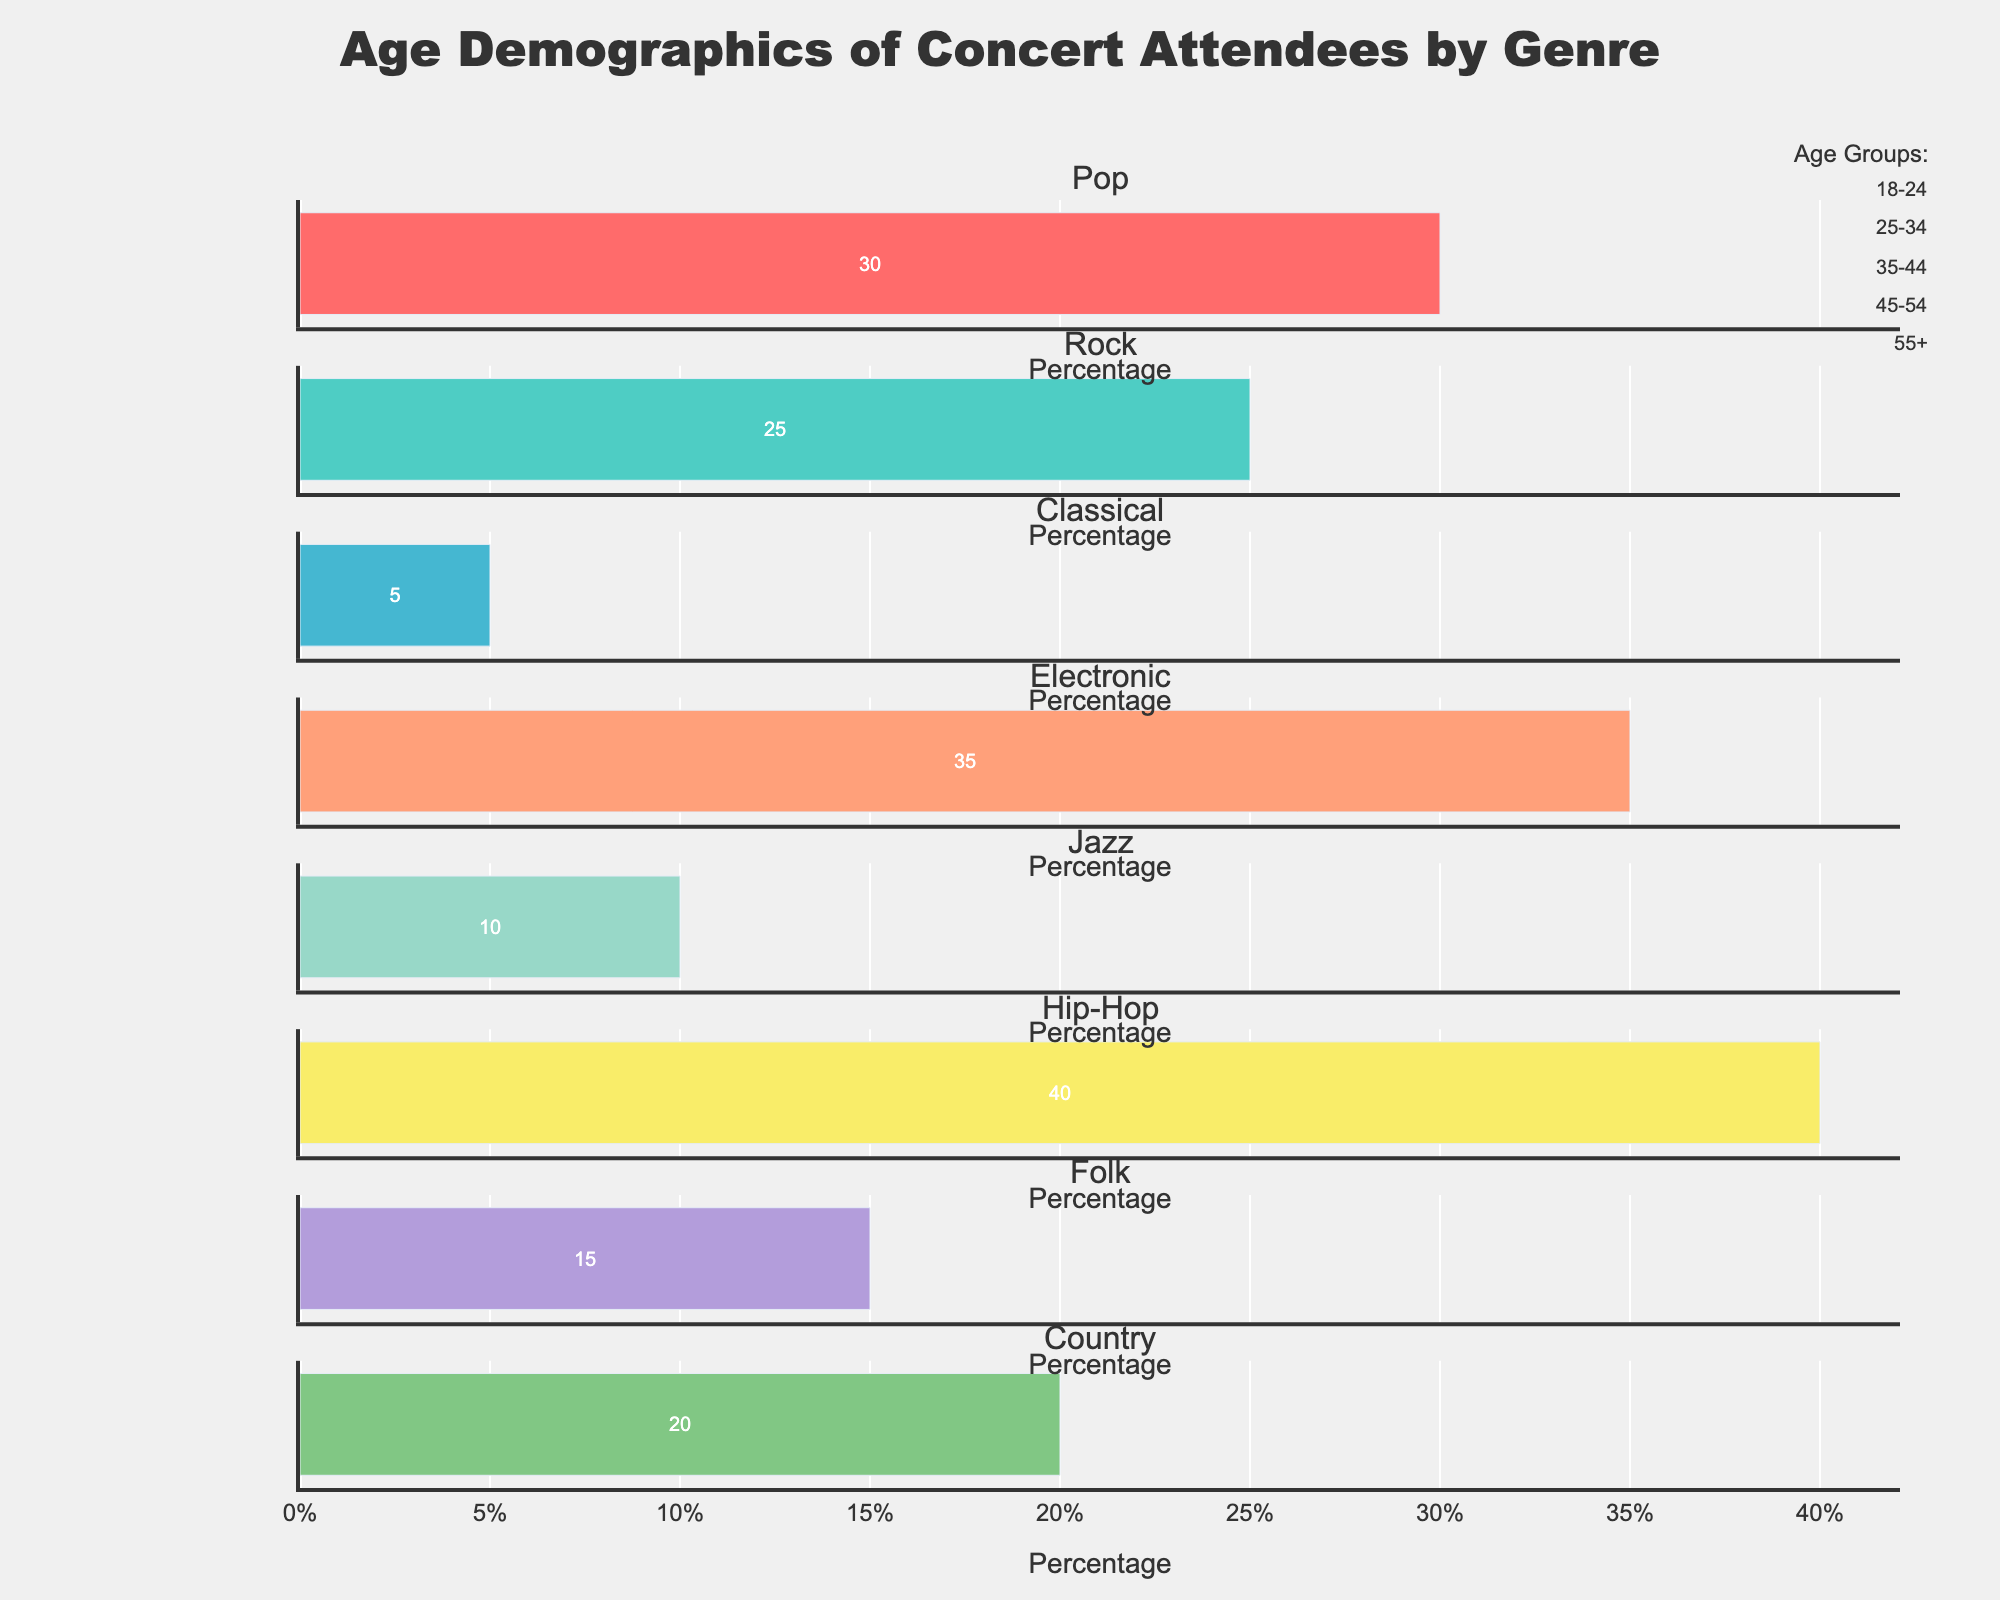What's the title of the figure? The title of the figure is located at the top and center of the plot. It is clearly displayed in bold text.
Answer: Age Demographics of Concert Attendees by Genre Which age group has the highest percentage attendance for Pop music? For Pop music, the age group with the highest percentage is represented by the longest bar under the Pop music subplot.
Answer: 18-24 How does the attendance of the 25-34 age group in Classical music compare to Electronic music? To find this, observe the lengths of the bars under the '25-34' category for both Classical and Electronic music genres.
Answer: In Classical music, it's 10%, and in Electronic music, it's 30% Which music genre has the least variation in age demographics? To determine this, we need to look at the subplot with bars of roughly equal lengths across all age groups.
Answer: Jazz What is the combined percentage of attendees aged 35 and above in Rock music? Sum the percentages of the '35-44', '45-54', and '55+' age groups for Rock music (25% + 15% + 5%).
Answer: 45% Is the percentage of attendees aged 55 and above greater in Classical music or Jazz music? Compare the lengths of the '55+' age group bars in the subplots for Classical and Jazz music.
Answer: Classical How many age groups have at least 20% attendance in Hip-Hop music? Count the bars that are greater than or equal to 20% in the Hip-Hop subplot.
Answer: Three age groups Which genre has the highest percentage of attendees in the 18-24 age group? Identify the genre with the longest bar in the '18-24' category across all subplots.
Answer: Hip-Hop What is the difference in attendance percentage between the 25-34 and 45-54 age groups for Country music? Subtract the percentage of the '45-54' age group from the '25-34' age group for Country music.
Answer: 25 - 20 = 5% What is the average percentage of attendees aged 45-54 across all genres? Add the '45-54' percentages for all genres and divide by the number of genres (15+15+30+10+25+7+25+20)/8.
Answer: 18.375% 